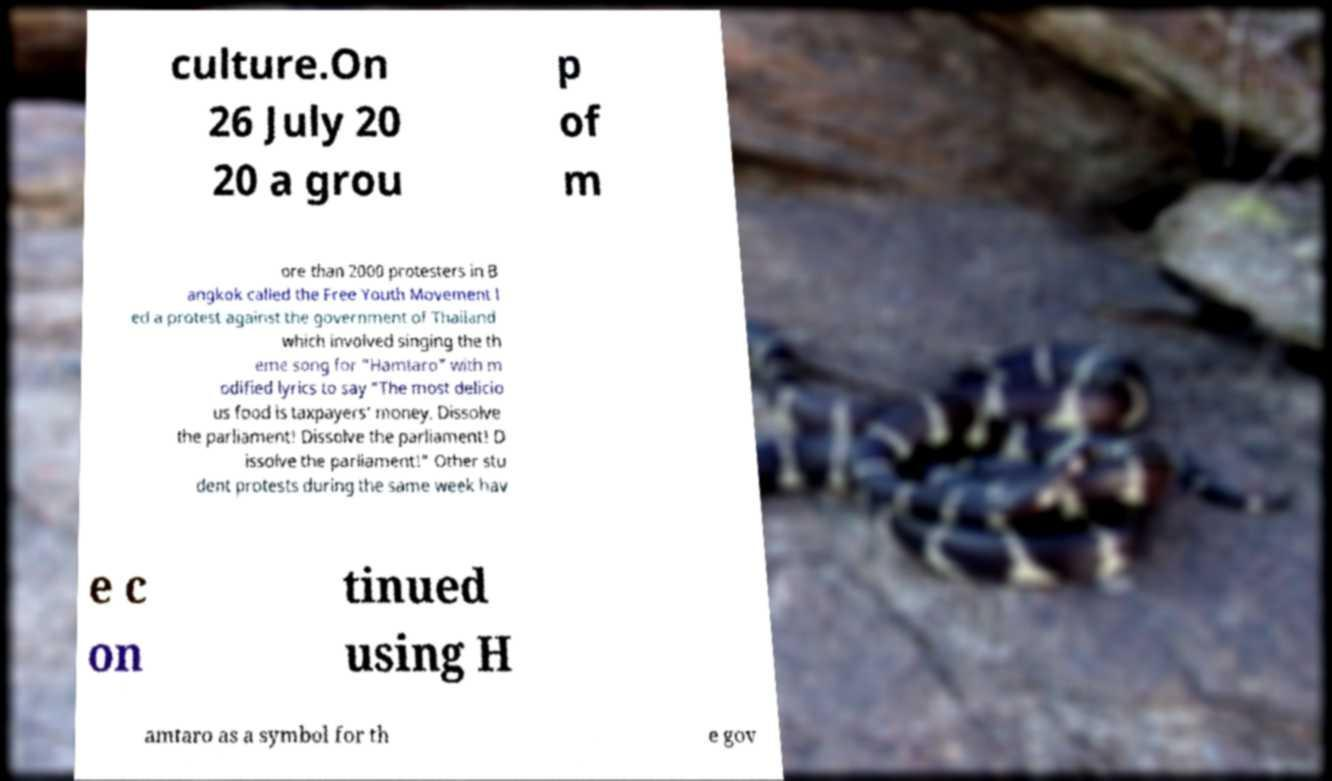Could you extract and type out the text from this image? culture.On 26 July 20 20 a grou p of m ore than 2000 protesters in B angkok called the Free Youth Movement l ed a protest against the government of Thailand which involved singing the th eme song for "Hamtaro" with m odified lyrics to say "The most delicio us food is taxpayers’ money. Dissolve the parliament! Dissolve the parliament! D issolve the parliament!" Other stu dent protests during the same week hav e c on tinued using H amtaro as a symbol for th e gov 